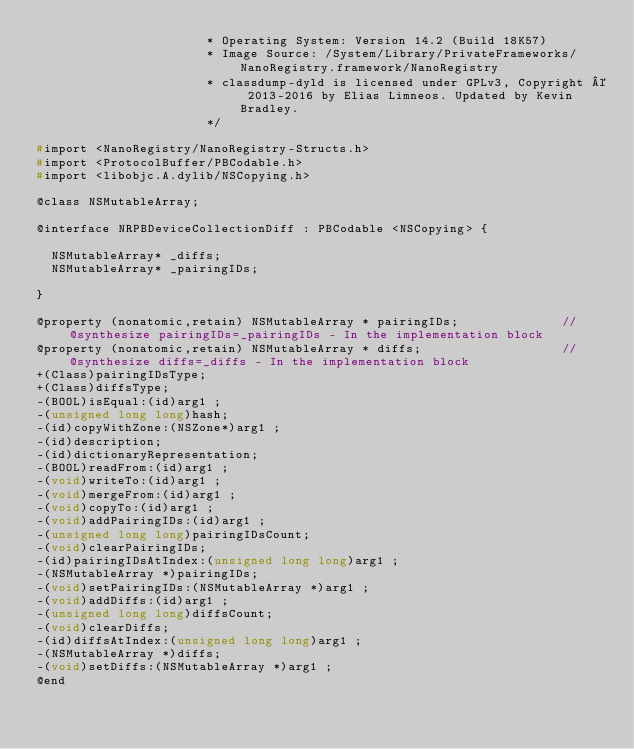<code> <loc_0><loc_0><loc_500><loc_500><_C_>                       * Operating System: Version 14.2 (Build 18K57)
                       * Image Source: /System/Library/PrivateFrameworks/NanoRegistry.framework/NanoRegistry
                       * classdump-dyld is licensed under GPLv3, Copyright © 2013-2016 by Elias Limneos. Updated by Kevin Bradley.
                       */

#import <NanoRegistry/NanoRegistry-Structs.h>
#import <ProtocolBuffer/PBCodable.h>
#import <libobjc.A.dylib/NSCopying.h>

@class NSMutableArray;

@interface NRPBDeviceCollectionDiff : PBCodable <NSCopying> {

	NSMutableArray* _diffs;
	NSMutableArray* _pairingIDs;

}

@property (nonatomic,retain) NSMutableArray * pairingIDs;              //@synthesize pairingIDs=_pairingIDs - In the implementation block
@property (nonatomic,retain) NSMutableArray * diffs;                   //@synthesize diffs=_diffs - In the implementation block
+(Class)pairingIDsType;
+(Class)diffsType;
-(BOOL)isEqual:(id)arg1 ;
-(unsigned long long)hash;
-(id)copyWithZone:(NSZone*)arg1 ;
-(id)description;
-(id)dictionaryRepresentation;
-(BOOL)readFrom:(id)arg1 ;
-(void)writeTo:(id)arg1 ;
-(void)mergeFrom:(id)arg1 ;
-(void)copyTo:(id)arg1 ;
-(void)addPairingIDs:(id)arg1 ;
-(unsigned long long)pairingIDsCount;
-(void)clearPairingIDs;
-(id)pairingIDsAtIndex:(unsigned long long)arg1 ;
-(NSMutableArray *)pairingIDs;
-(void)setPairingIDs:(NSMutableArray *)arg1 ;
-(void)addDiffs:(id)arg1 ;
-(unsigned long long)diffsCount;
-(void)clearDiffs;
-(id)diffsAtIndex:(unsigned long long)arg1 ;
-(NSMutableArray *)diffs;
-(void)setDiffs:(NSMutableArray *)arg1 ;
@end

</code> 